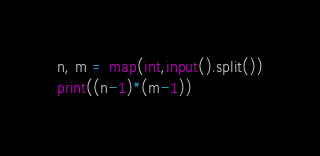<code> <loc_0><loc_0><loc_500><loc_500><_Python_>n, m = map(int,input().split())
print((n-1)*(m-1))</code> 